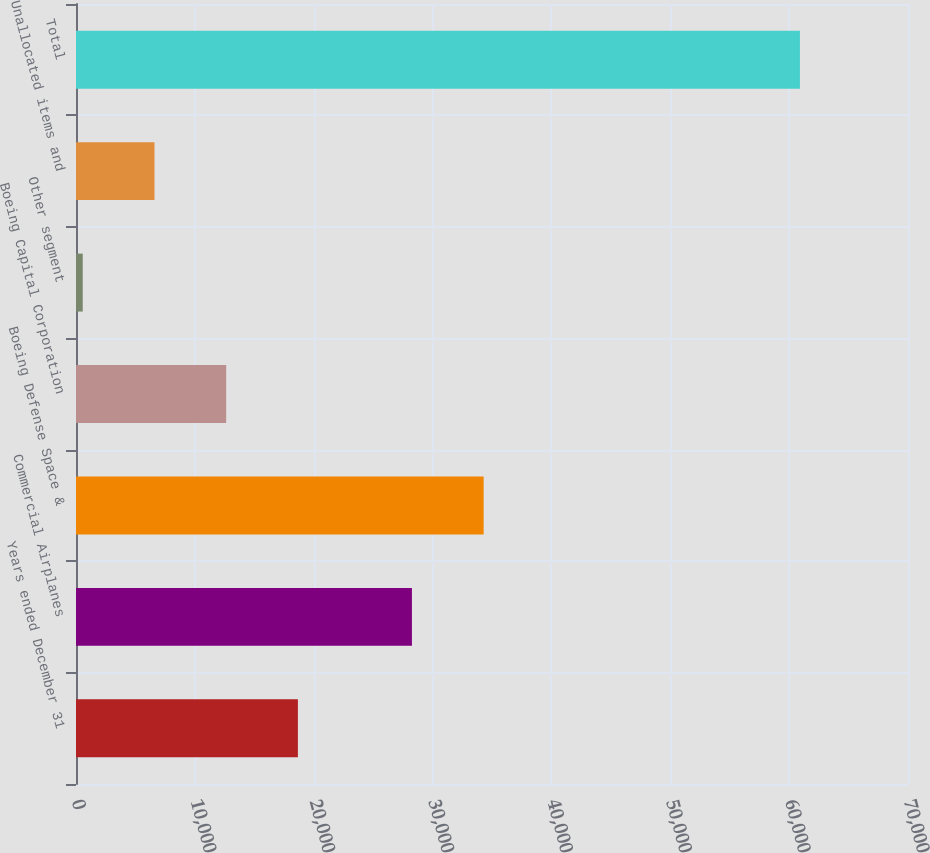Convert chart to OTSL. <chart><loc_0><loc_0><loc_500><loc_500><bar_chart><fcel>Years ended December 31<fcel>Commercial Airplanes<fcel>Boeing Defense Space &<fcel>Boeing Capital Corporation<fcel>Other segment<fcel>Unallocated items and<fcel>Total<nl><fcel>18669.6<fcel>28263<fcel>34297.2<fcel>12635.4<fcel>567<fcel>6601.2<fcel>60909<nl></chart> 